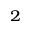<formula> <loc_0><loc_0><loc_500><loc_500>_ { 2 }</formula> 